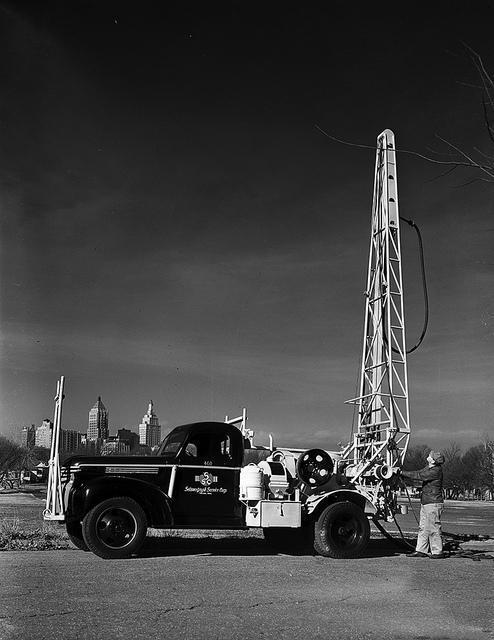How many red chairs are there?
Give a very brief answer. 0. 